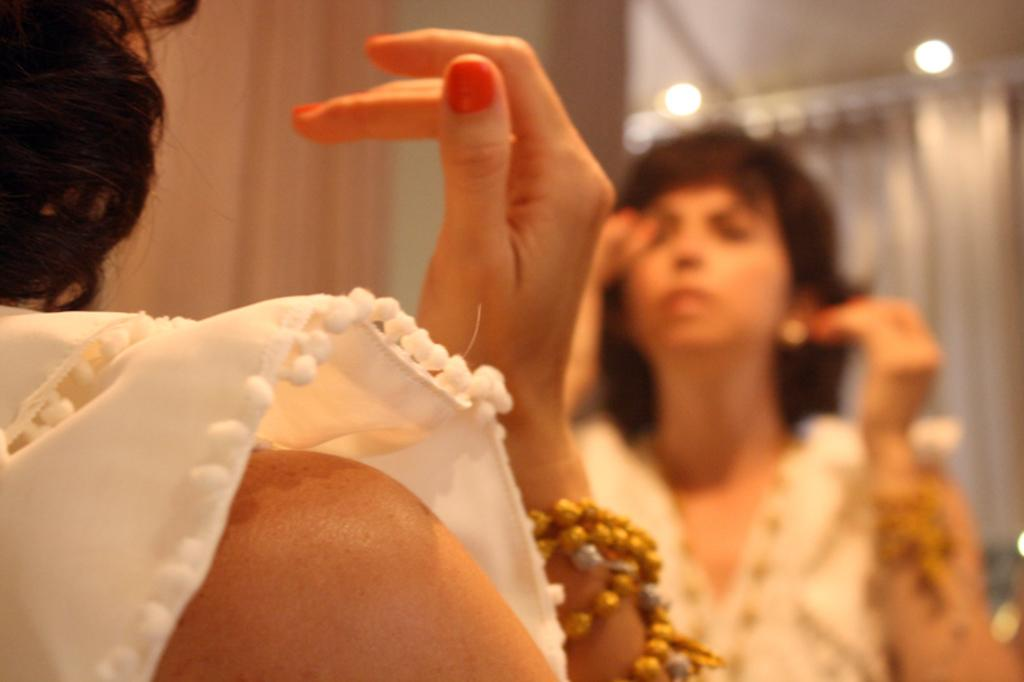What is the main subject of the image? There is a person standing in the image. What can be seen in front of the person? There is a reflection in front of the person. How would you describe the background of the image? The background of the image appears blurred. What type of dinosaur can be seen in the background of the image? There are no dinosaurs present in the image; the background appears blurred but does not show any dinosaurs. Can you tell me how many insects are crawling on the person's shoulder in the image? There are no insects visible on the person's shoulder in the image. 